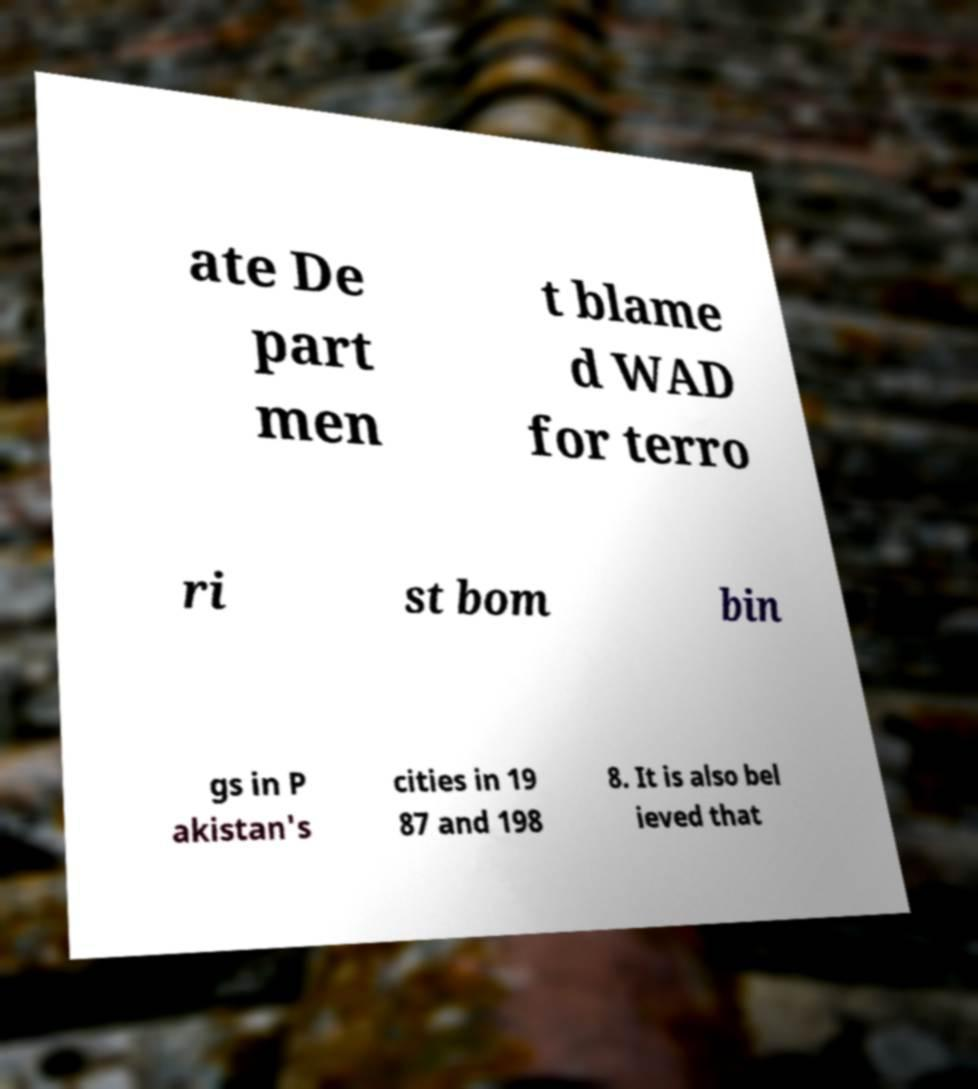What messages or text are displayed in this image? I need them in a readable, typed format. ate De part men t blame d WAD for terro ri st bom bin gs in P akistan's cities in 19 87 and 198 8. It is also bel ieved that 